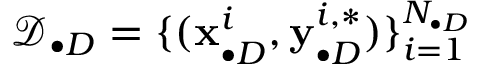<formula> <loc_0><loc_0><loc_500><loc_500>\mathcal { D } _ { \bullet D } = \{ ( x _ { \bullet D } ^ { i } , y _ { \bullet D } ^ { i , * } ) \} _ { i = 1 } ^ { N _ { \bullet D } }</formula> 